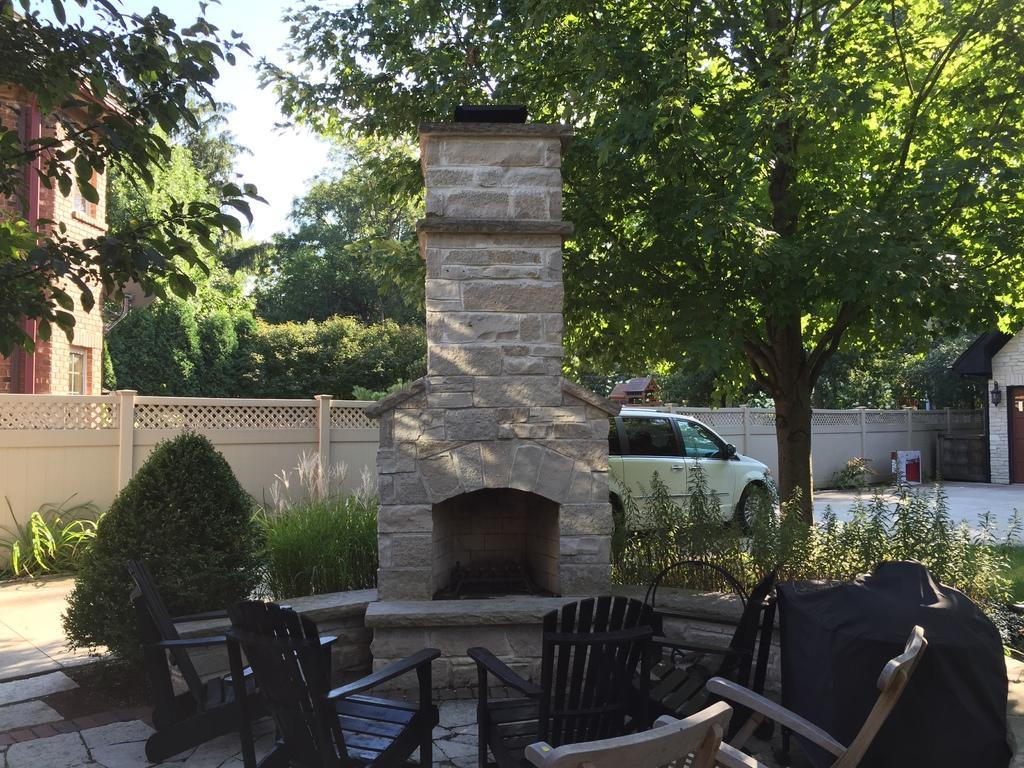Could you give a brief overview of what you see in this image? This is a picture taken in the outdoors. It is sunny. There are chairs and tables and a pillar and a car and trees. Background of the pillar is a building and sky. 